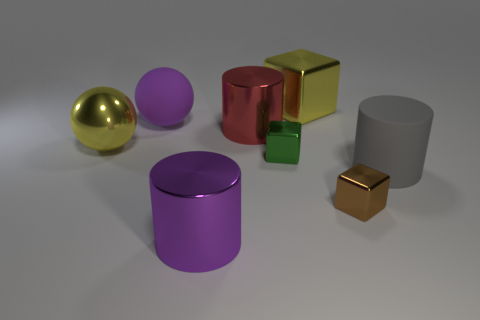The red shiny cylinder is what size?
Ensure brevity in your answer.  Large. Are there more cylinders to the left of the big purple metallic cylinder than gray matte balls?
Give a very brief answer. No. Are there the same number of big red metallic cylinders that are in front of the yellow ball and large purple balls that are on the right side of the yellow shiny cube?
Offer a terse response. Yes. There is a block that is both in front of the yellow block and right of the green metallic object; what color is it?
Your answer should be compact. Brown. Is the number of large matte objects that are on the right side of the large purple metallic cylinder greater than the number of blocks on the left side of the purple matte thing?
Your response must be concise. Yes. There is a matte object that is left of the purple metal cylinder; is its size the same as the large metallic block?
Your answer should be very brief. Yes. There is a metallic object to the left of the big cylinder that is in front of the large gray rubber thing; what number of cubes are left of it?
Ensure brevity in your answer.  0. What size is the metallic thing that is left of the large red metallic cylinder and right of the big shiny ball?
Your response must be concise. Large. What number of other things are the same shape as the gray matte thing?
Offer a terse response. 2. There is a small brown block; how many rubber objects are to the left of it?
Offer a terse response. 1. 